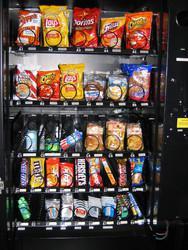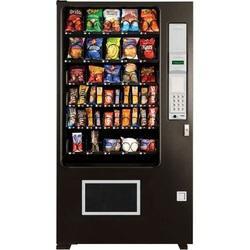The first image is the image on the left, the second image is the image on the right. Assess this claim about the two images: "The dispensing port of the vending machine in the image on the right is outlined in gray.". Correct or not? Answer yes or no. Yes. 